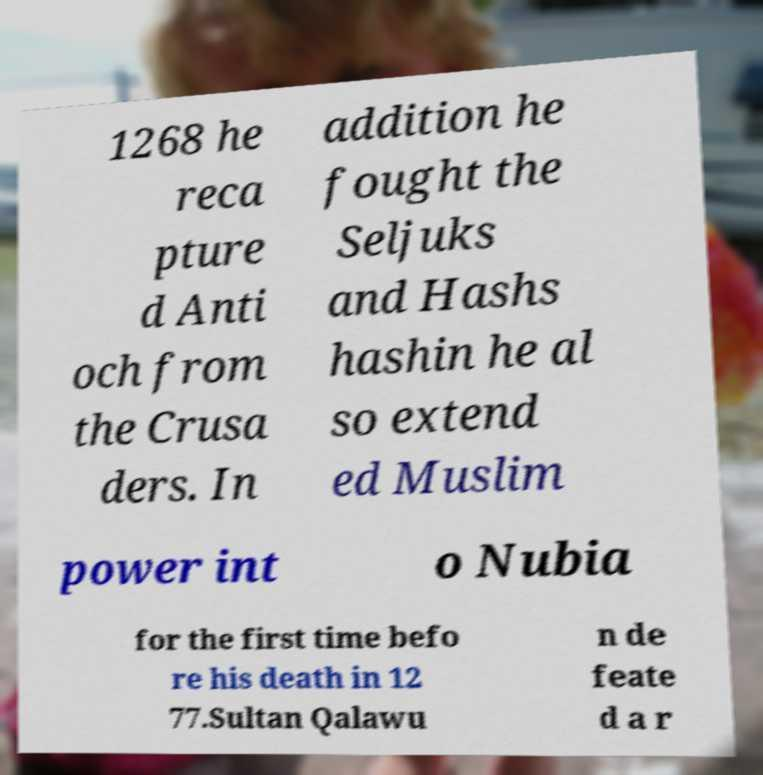Please read and relay the text visible in this image. What does it say? 1268 he reca pture d Anti och from the Crusa ders. In addition he fought the Seljuks and Hashs hashin he al so extend ed Muslim power int o Nubia for the first time befo re his death in 12 77.Sultan Qalawu n de feate d a r 